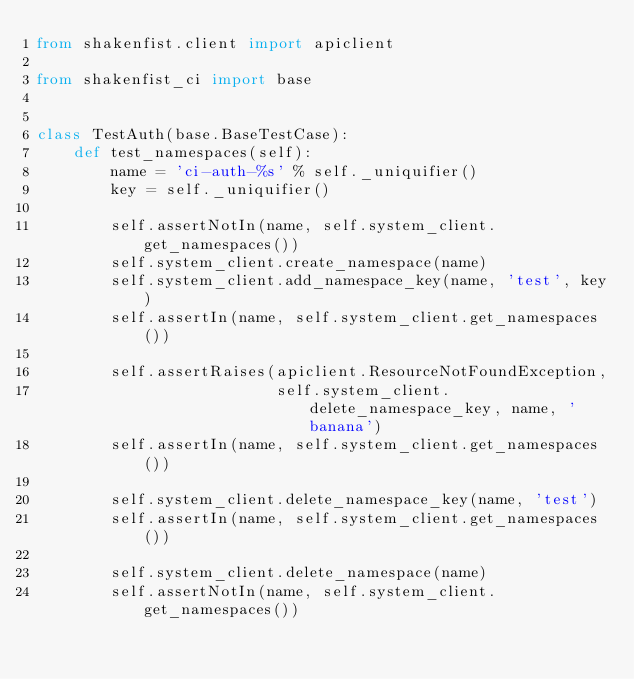<code> <loc_0><loc_0><loc_500><loc_500><_Python_>from shakenfist.client import apiclient

from shakenfist_ci import base


class TestAuth(base.BaseTestCase):
    def test_namespaces(self):
        name = 'ci-auth-%s' % self._uniquifier()
        key = self._uniquifier()

        self.assertNotIn(name, self.system_client.get_namespaces())
        self.system_client.create_namespace(name)
        self.system_client.add_namespace_key(name, 'test', key)
        self.assertIn(name, self.system_client.get_namespaces())

        self.assertRaises(apiclient.ResourceNotFoundException,
                          self.system_client.delete_namespace_key, name, 'banana')
        self.assertIn(name, self.system_client.get_namespaces())

        self.system_client.delete_namespace_key(name, 'test')
        self.assertIn(name, self.system_client.get_namespaces())

        self.system_client.delete_namespace(name)
        self.assertNotIn(name, self.system_client.get_namespaces())
</code> 